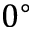Convert formula to latex. <formula><loc_0><loc_0><loc_500><loc_500>0 ^ { \circ }</formula> 